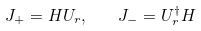Convert formula to latex. <formula><loc_0><loc_0><loc_500><loc_500>J _ { + } = H U _ { r } , \quad J _ { - } = U _ { r } ^ { \dagger } H</formula> 